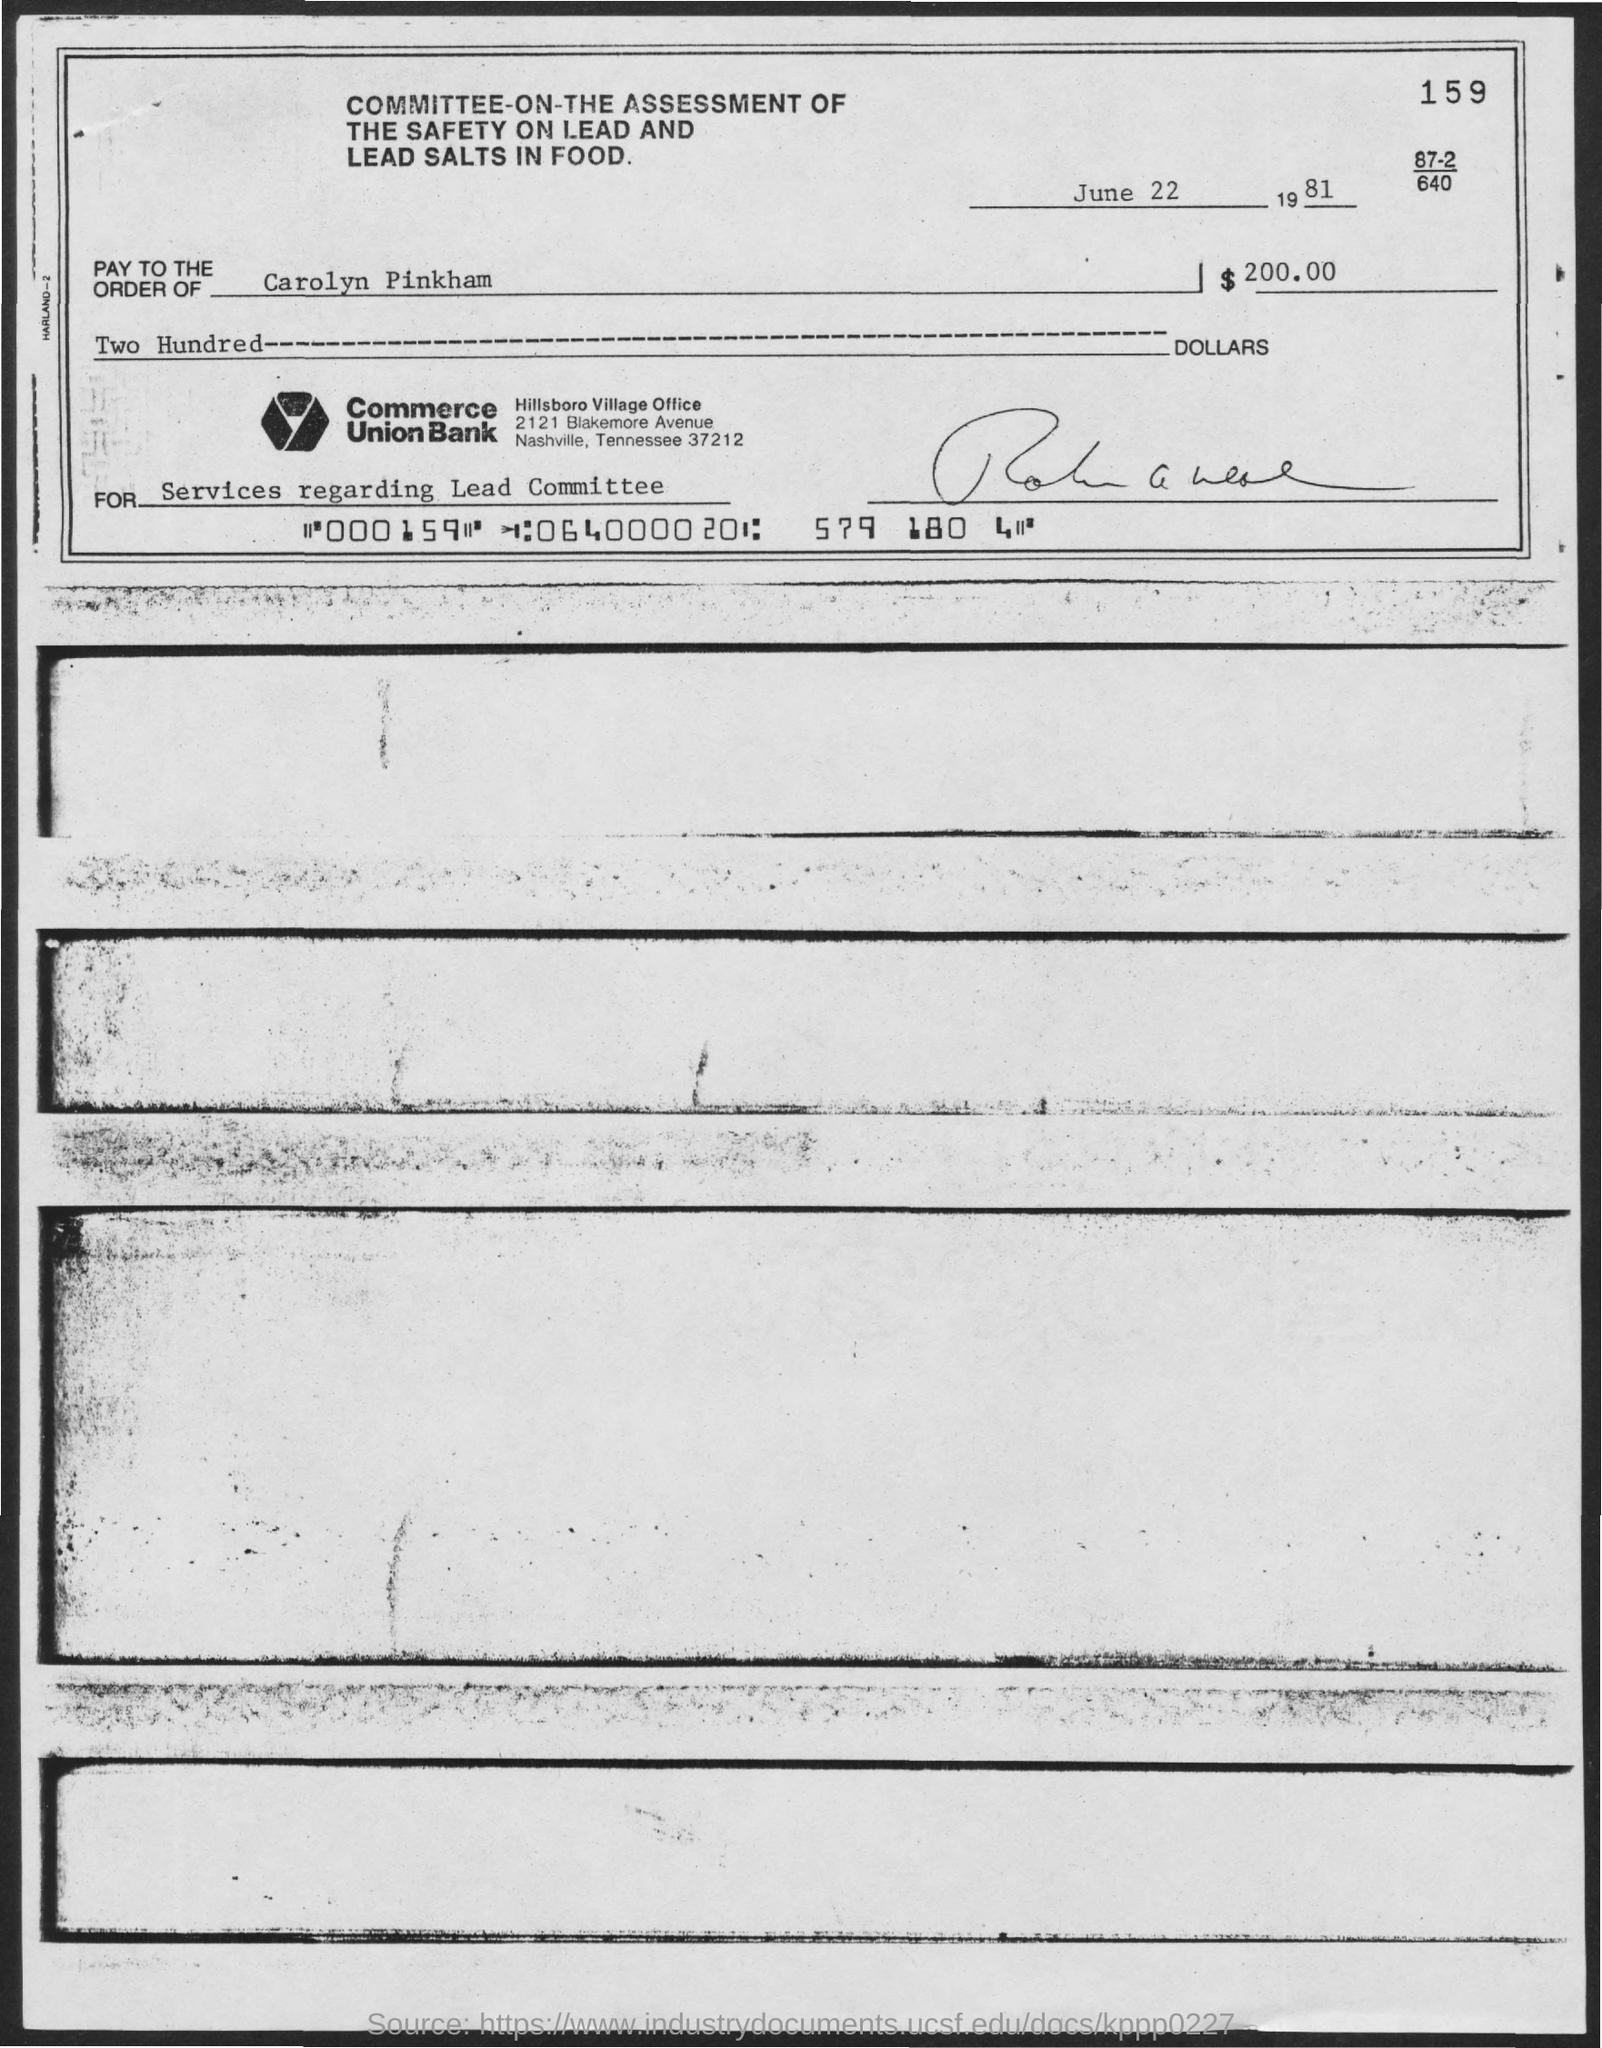In whose name, the check is payable?
Your answer should be compact. Carolyn Pinkham. What is the check dated?
Offer a terse response. June 22 1981. What is the amount of check issued?
Your answer should be compact. $ 200.00. What are the services offered for the check amount?
Your answer should be very brief. SERVICES REGARDING LEAD COMMITTEE. Which bank has issued this check?
Give a very brief answer. Commerce Union Bank. 